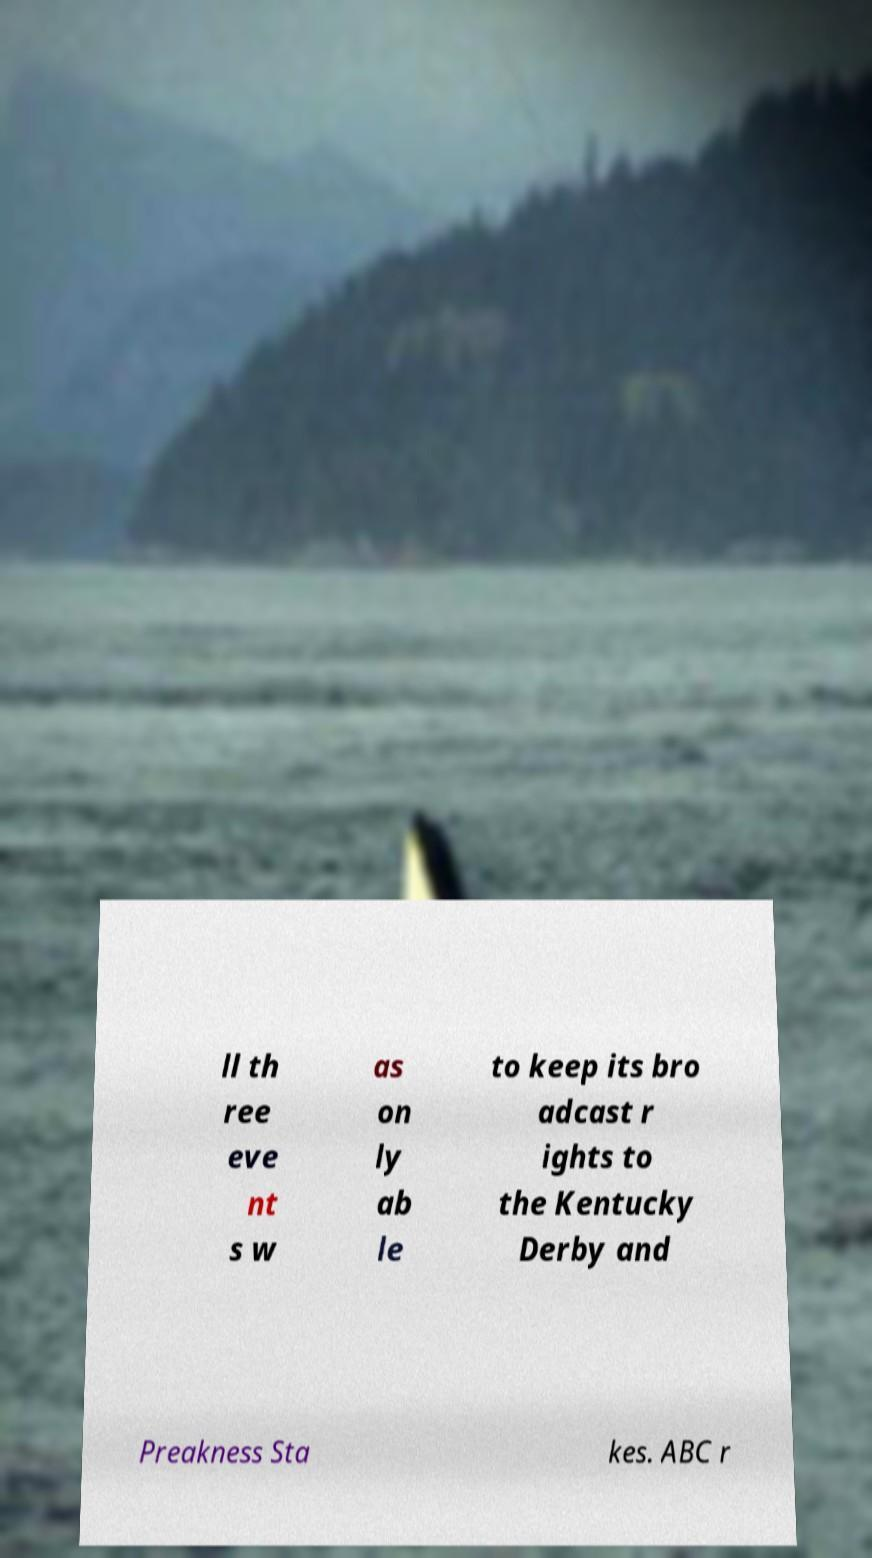For documentation purposes, I need the text within this image transcribed. Could you provide that? ll th ree eve nt s w as on ly ab le to keep its bro adcast r ights to the Kentucky Derby and Preakness Sta kes. ABC r 